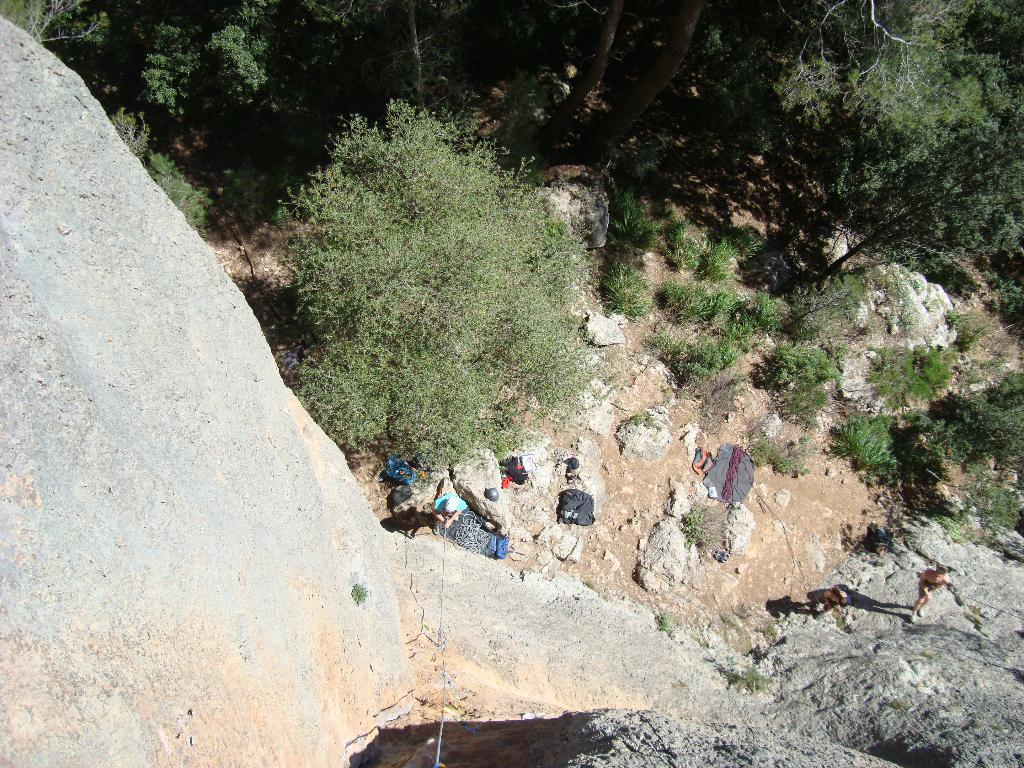What type of natural elements can be seen in the image? There are trees in the image. What objects are present in the image that might be used for carrying items? There are bags in the image. What type of material is visible in the image that might be used for tying or securing objects? There are ropes in the image. What can be observed in the image that indicates the presence of light and shadows? There are shadows in the image. What living beings are present in the image? There are people standing in the image. What type of stove is visible in the image? There is no stove present in the image. How does the behavior of the people in the image change throughout the day? The provided facts do not give any information about the behavior of the people in the image or how it might change throughout the day. 